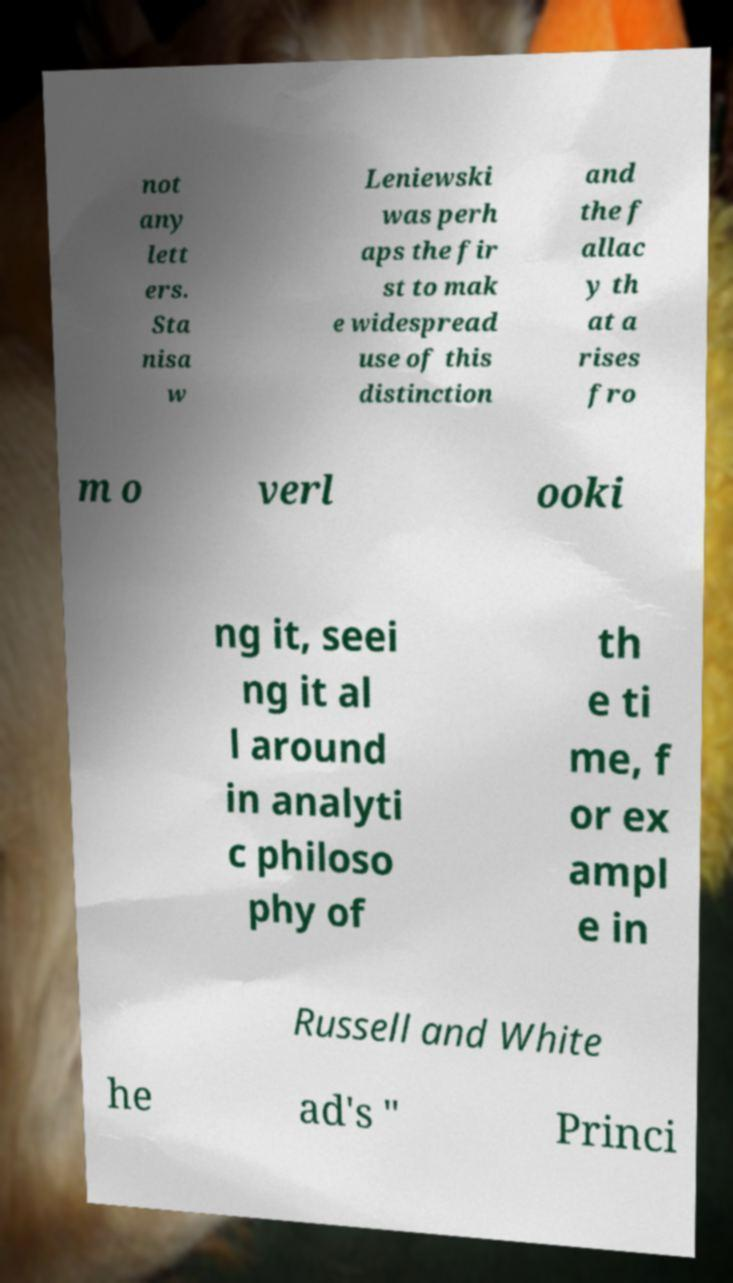There's text embedded in this image that I need extracted. Can you transcribe it verbatim? not any lett ers. Sta nisa w Leniewski was perh aps the fir st to mak e widespread use of this distinction and the f allac y th at a rises fro m o verl ooki ng it, seei ng it al l around in analyti c philoso phy of th e ti me, f or ex ampl e in Russell and White he ad's " Princi 